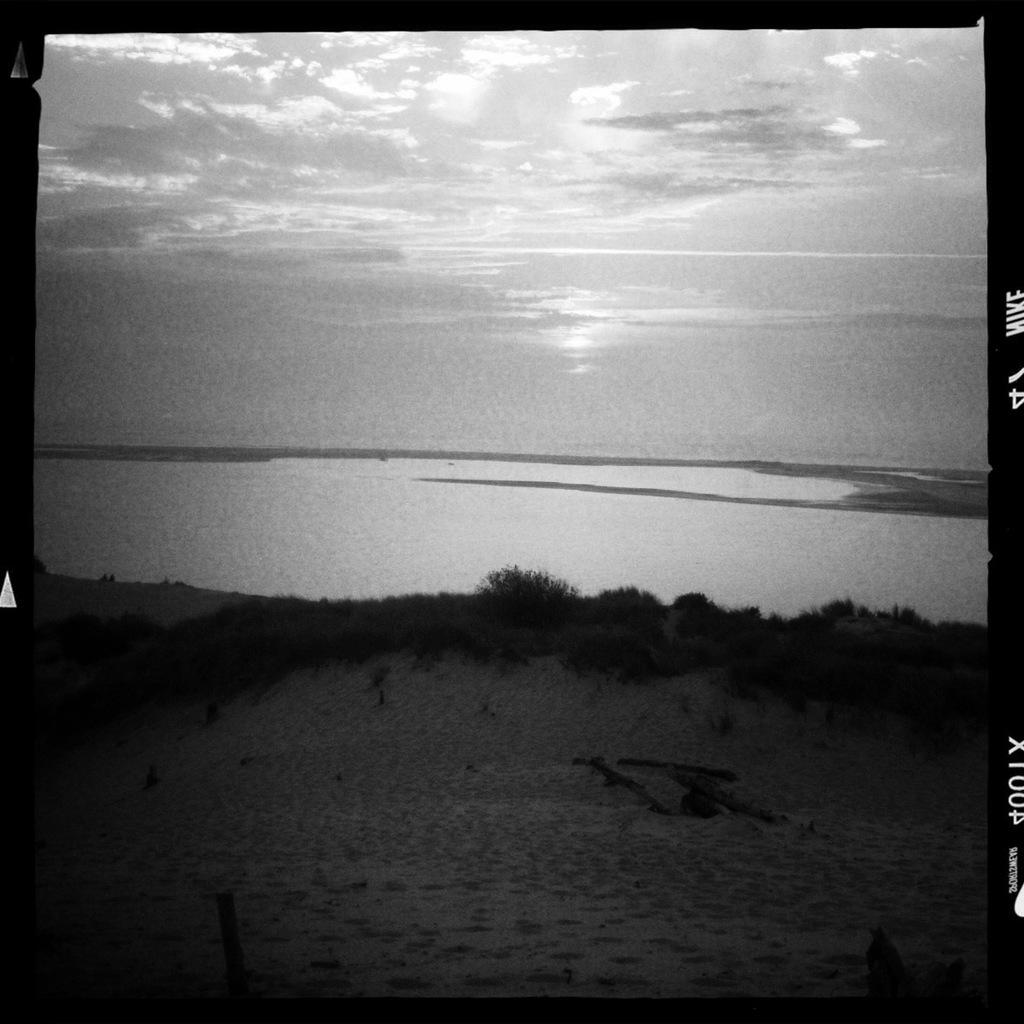What is the main feature in the center of the image? There is a lake in the center of the image. What can be seen at the bottom of the image? Shrubs and sand are visible at the bottom of the image. What is visible in the background of the image? There is sky visible in the background of the image. What is the name of the fairy standing on the sand in the image? There are no fairies present in the image; it features a lake, shrubs, sand, and sky. 